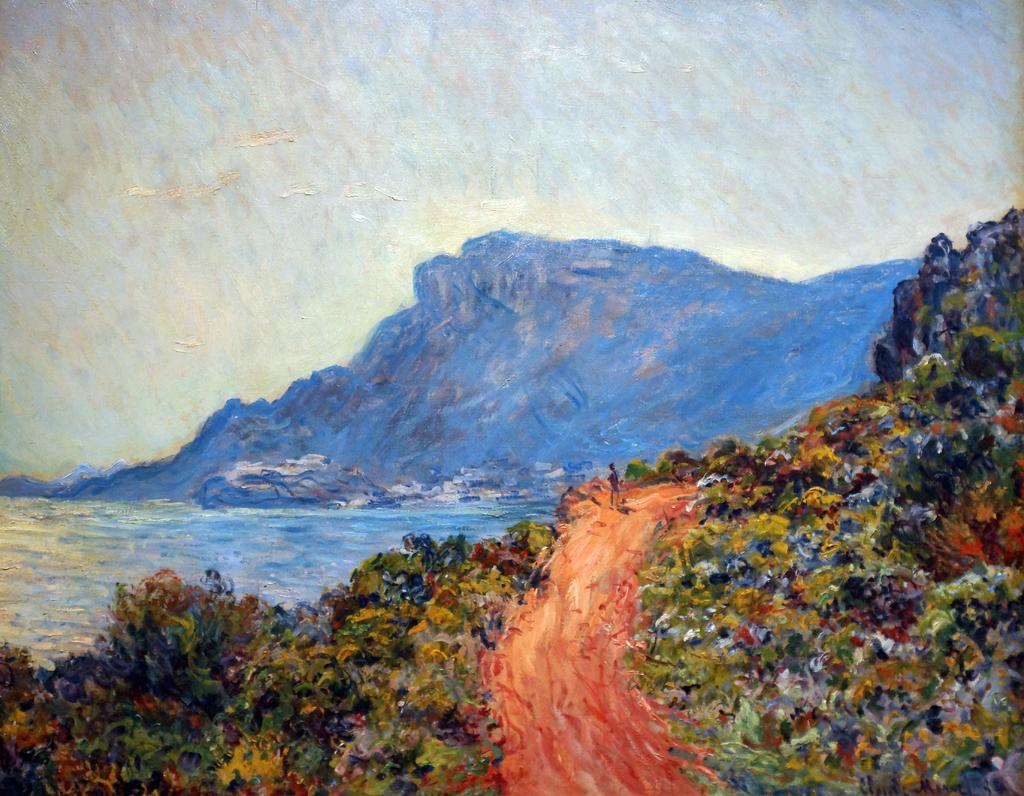What type of artwork is depicted in the image? The image appears to be a painting. What geographical feature can be seen in the image? There is a hill in the image. What type of vegetation is present in the image? There are trees in the image. What natural element is visible in the image? There is water visible in the image. What type of shoes can be seen in the image? There are no shoes present in the image; it is a painting of a landscape. Can you describe the level of detail in the painting? The level of detail in the painting cannot be determined from the image alone, as it depends on the artist's style and technique. 